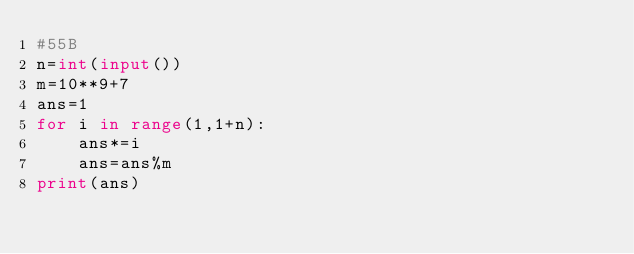Convert code to text. <code><loc_0><loc_0><loc_500><loc_500><_Python_>#55B
n=int(input())
m=10**9+7
ans=1
for i in range(1,1+n):
    ans*=i
    ans=ans%m
print(ans)</code> 